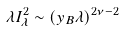Convert formula to latex. <formula><loc_0><loc_0><loc_500><loc_500>\lambda I ^ { 2 } _ { \lambda } \sim ( y _ { B } \lambda ) ^ { 2 \nu - 2 }</formula> 